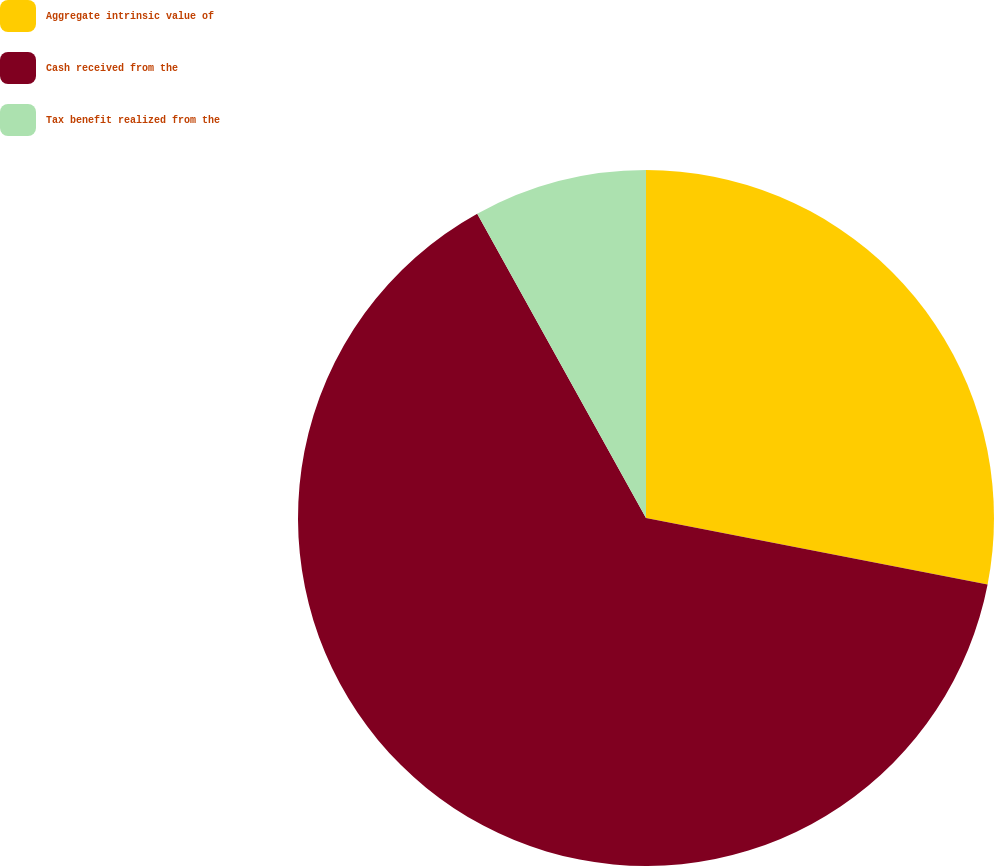Convert chart to OTSL. <chart><loc_0><loc_0><loc_500><loc_500><pie_chart><fcel>Aggregate intrinsic value of<fcel>Cash received from the<fcel>Tax benefit realized from the<nl><fcel>28.06%<fcel>63.89%<fcel>8.06%<nl></chart> 